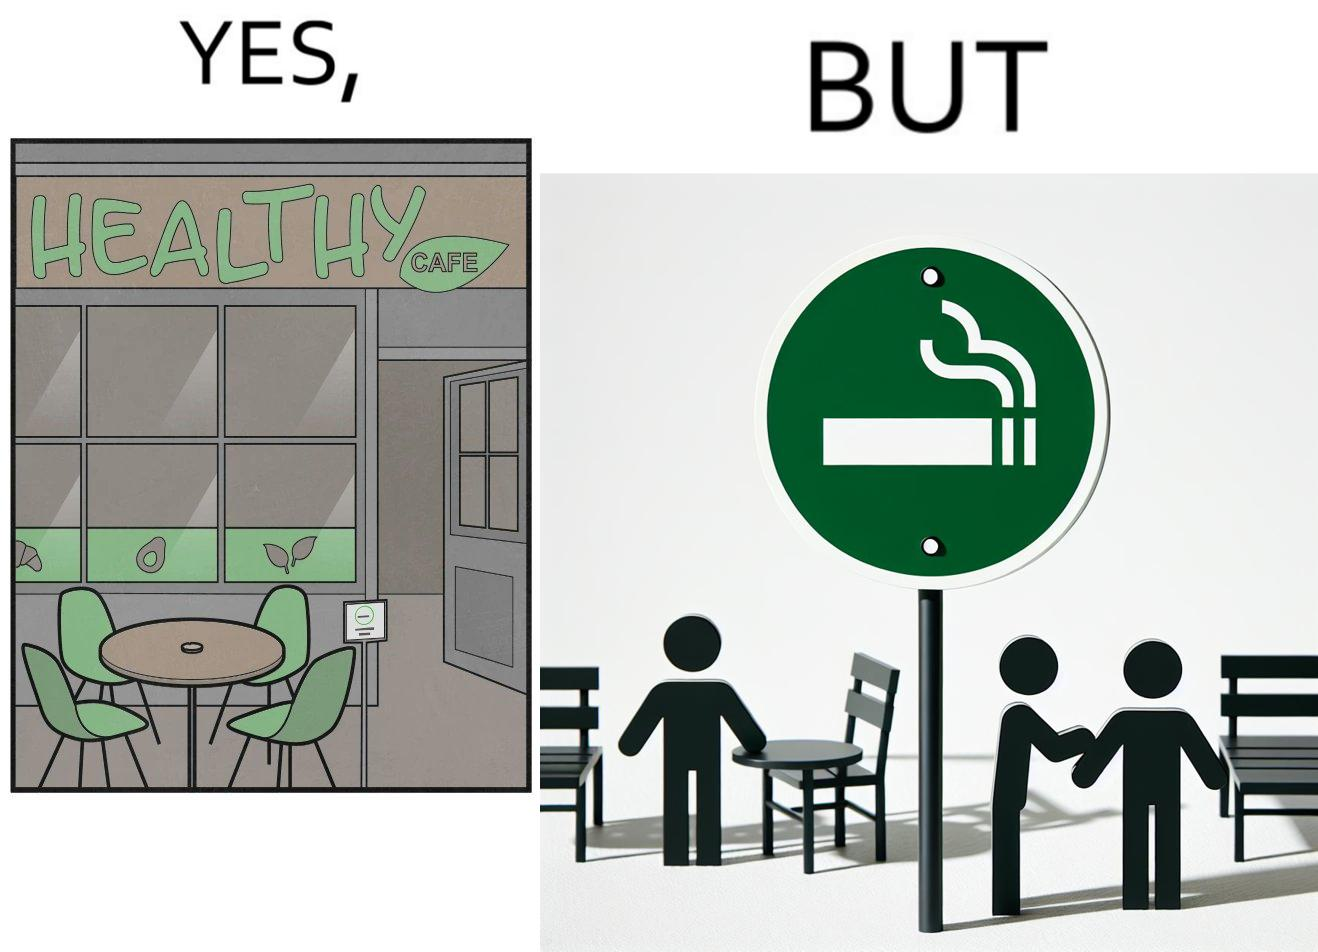Would you classify this image as satirical? Yes, this image is satirical. 